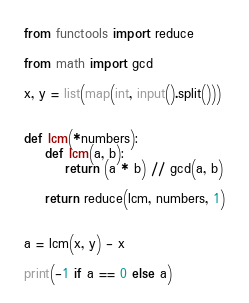<code> <loc_0><loc_0><loc_500><loc_500><_Python_>from functools import reduce

from math import gcd

x, y = list(map(int, input().split()))


def lcm(*numbers):
    def lcm(a, b):
        return (a * b) // gcd(a, b)

    return reduce(lcm, numbers, 1)


a = lcm(x, y) - x

print(-1 if a == 0 else a)
</code> 